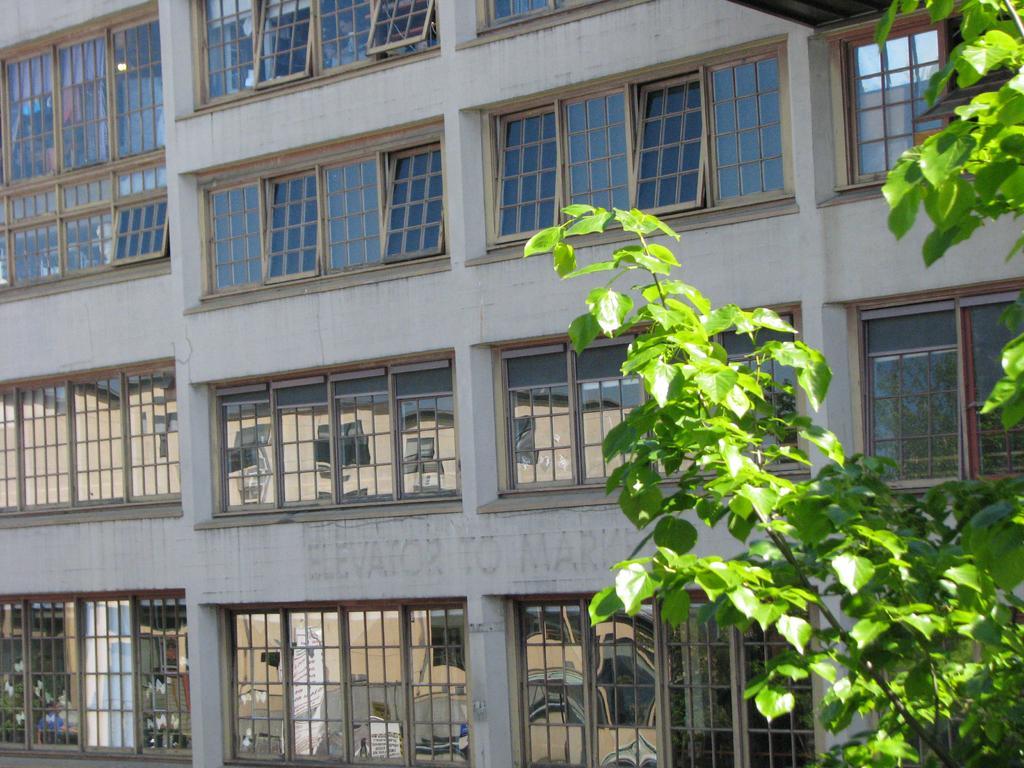Can you describe this image briefly? In the picture we can see a part of the building with many windows and glasses to it and beside it we can see a part of the plant. 